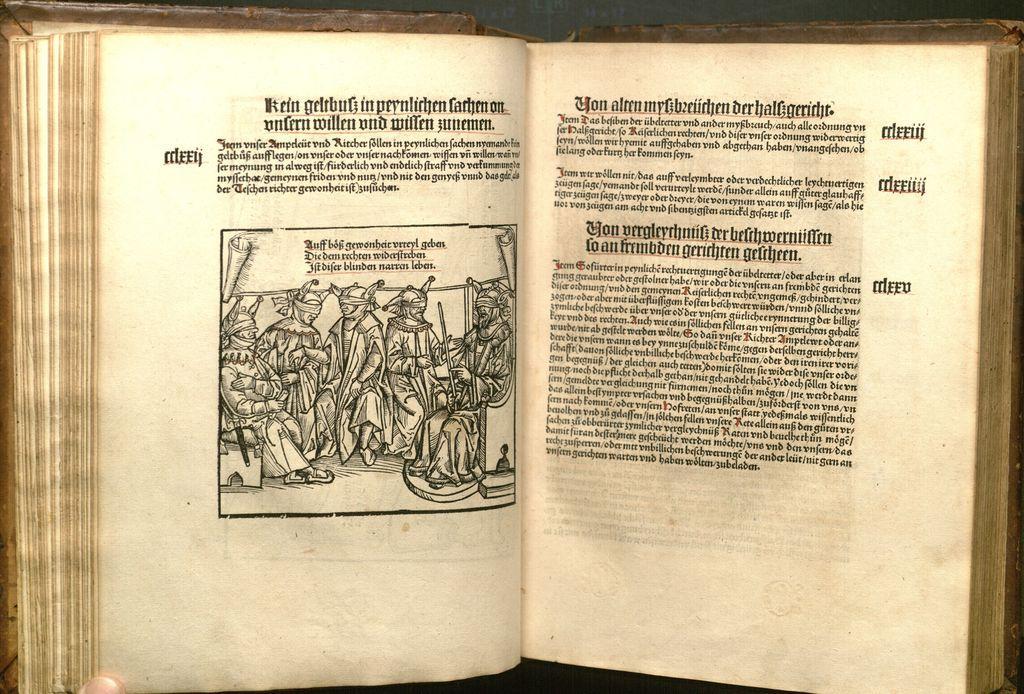Could you give a brief overview of what you see in this image? In this picture, we can see a book and on the paper there is an image of people and on the papers it is written something. 